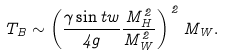Convert formula to latex. <formula><loc_0><loc_0><loc_500><loc_500>T _ { B } \sim \left ( \frac { \gamma \sin t w } { 4 g } \frac { M _ { H } ^ { 2 } } { M _ { W } ^ { 2 } } \right ) ^ { \, 2 } M _ { W } .</formula> 